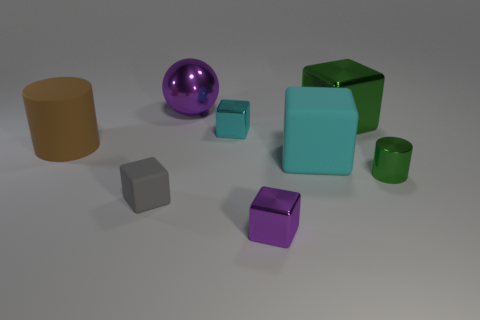Subtract all green blocks. How many blocks are left? 4 Subtract all cyan metallic blocks. How many blocks are left? 4 Subtract all gray cubes. Subtract all purple cylinders. How many cubes are left? 4 Add 2 tiny metal cylinders. How many objects exist? 10 Subtract all blocks. How many objects are left? 3 Add 7 rubber blocks. How many rubber blocks are left? 9 Add 8 cyan matte cubes. How many cyan matte cubes exist? 9 Subtract 1 gray blocks. How many objects are left? 7 Subtract all small rubber blocks. Subtract all small purple shiny things. How many objects are left? 6 